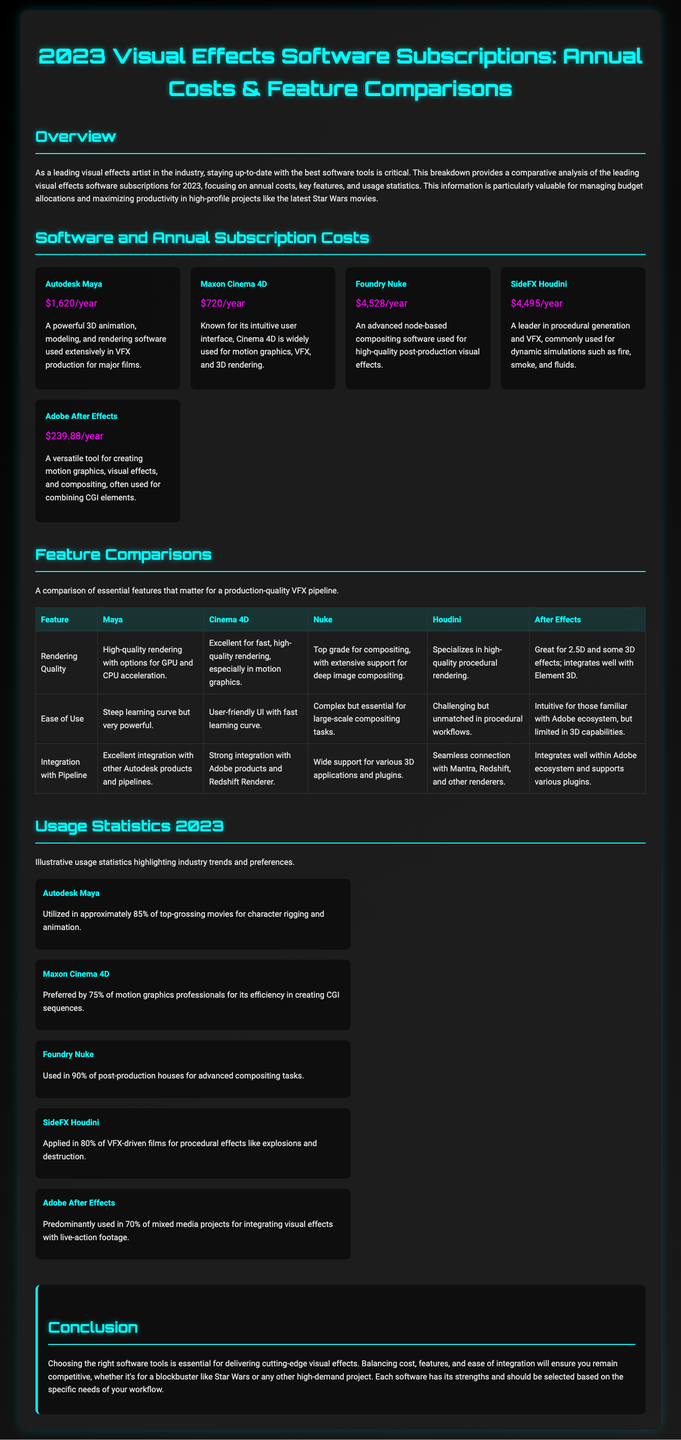what is the annual cost of Autodesk Maya? The annual cost of Autodesk Maya is provided in the document under the pricing section.
Answer: $1,620/year which software is used in approximately 85% of top-grossing movies? Analysis of the usage statistics indicates the software utilized in this percentage of movies.
Answer: Autodesk Maya what feature is Nuke known for in the feature comparisons? By reviewing the feature comparison table, we see Nuke's specialization mentioned.
Answer: Extensive support for deep image compositing how many motion graphics professionals prefer Maxon Cinema 4D? The document includes statistics on software preference among motion graphics professionals.
Answer: 75% which software has the lowest annual subscription cost? Comparing the annual costs listed in the document identifies the software with the lowest price point.
Answer: Adobe After Effects how does Cinema 4D perform in terms of rendering quality? The feature comparison specifically highlights the rendering quality for Cinema 4D.
Answer: Excellent for fast, high-quality rendering what is the concluding statement about choosing software tools? The conclusion section encapsulates the main advice regarding software tool selection.
Answer: Balancing cost, features, and ease of integration which software is primarily used for integrating visual effects with live-action footage? The usage statistics provide details on the specific software's application in mixed media projects.
Answer: Adobe After Effects what is the purpose of the document? The overview section presents the aim and relevance of the information contained within the document.
Answer: Comparative analysis of visual effects software subscriptions 